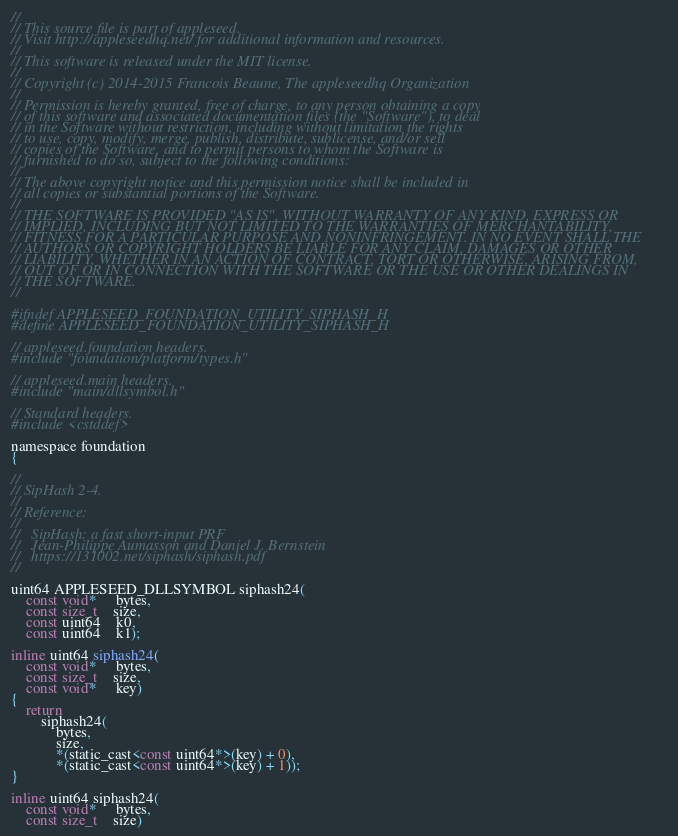<code> <loc_0><loc_0><loc_500><loc_500><_C_>
//
// This source file is part of appleseed.
// Visit http://appleseedhq.net/ for additional information and resources.
//
// This software is released under the MIT license.
//
// Copyright (c) 2014-2015 Francois Beaune, The appleseedhq Organization
//
// Permission is hereby granted, free of charge, to any person obtaining a copy
// of this software and associated documentation files (the "Software"), to deal
// in the Software without restriction, including without limitation the rights
// to use, copy, modify, merge, publish, distribute, sublicense, and/or sell
// copies of the Software, and to permit persons to whom the Software is
// furnished to do so, subject to the following conditions:
//
// The above copyright notice and this permission notice shall be included in
// all copies or substantial portions of the Software.
//
// THE SOFTWARE IS PROVIDED "AS IS", WITHOUT WARRANTY OF ANY KIND, EXPRESS OR
// IMPLIED, INCLUDING BUT NOT LIMITED TO THE WARRANTIES OF MERCHANTABILITY,
// FITNESS FOR A PARTICULAR PURPOSE AND NONINFRINGEMENT. IN NO EVENT SHALL THE
// AUTHORS OR COPYRIGHT HOLDERS BE LIABLE FOR ANY CLAIM, DAMAGES OR OTHER
// LIABILITY, WHETHER IN AN ACTION OF CONTRACT, TORT OR OTHERWISE, ARISING FROM,
// OUT OF OR IN CONNECTION WITH THE SOFTWARE OR THE USE OR OTHER DEALINGS IN
// THE SOFTWARE.
//

#ifndef APPLESEED_FOUNDATION_UTILITY_SIPHASH_H
#define APPLESEED_FOUNDATION_UTILITY_SIPHASH_H

// appleseed.foundation headers.
#include "foundation/platform/types.h"

// appleseed.main headers.
#include "main/dllsymbol.h"

// Standard headers.
#include <cstddef>

namespace foundation
{

//
// SipHash 2-4.
//
// Reference:
//
//   SipHash: a fast short-input PRF
//   Jean-Philippe Aumasson and Daniel J. Bernstein
//   https://131002.net/siphash/siphash.pdf
//

uint64 APPLESEED_DLLSYMBOL siphash24(
    const void*     bytes,
    const size_t    size,
    const uint64    k0,
    const uint64    k1);

inline uint64 siphash24(
    const void*     bytes,
    const size_t    size,
    const void*     key)
{
    return
        siphash24(
            bytes,
            size,
            *(static_cast<const uint64*>(key) + 0),
            *(static_cast<const uint64*>(key) + 1));
}

inline uint64 siphash24(
    const void*     bytes,
    const size_t    size)</code> 